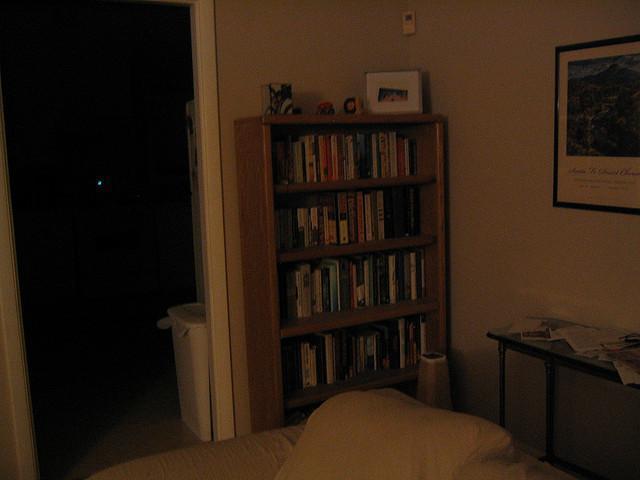How many bookcases are there?
Give a very brief answer. 1. How many pictures are hanging on the wall?
Give a very brief answer. 1. How many beds are in the bedroom?
Give a very brief answer. 1. How many shelves are visible?
Give a very brief answer. 4. How many books are open?
Give a very brief answer. 0. How many squares are on the poster?
Give a very brief answer. 1. How many pictures on the wall?
Give a very brief answer. 1. How many books are in the picture?
Give a very brief answer. 3. How many couches are in the picture?
Give a very brief answer. 1. How many people are doing a frontside bluntslide down a rail?
Give a very brief answer. 0. 